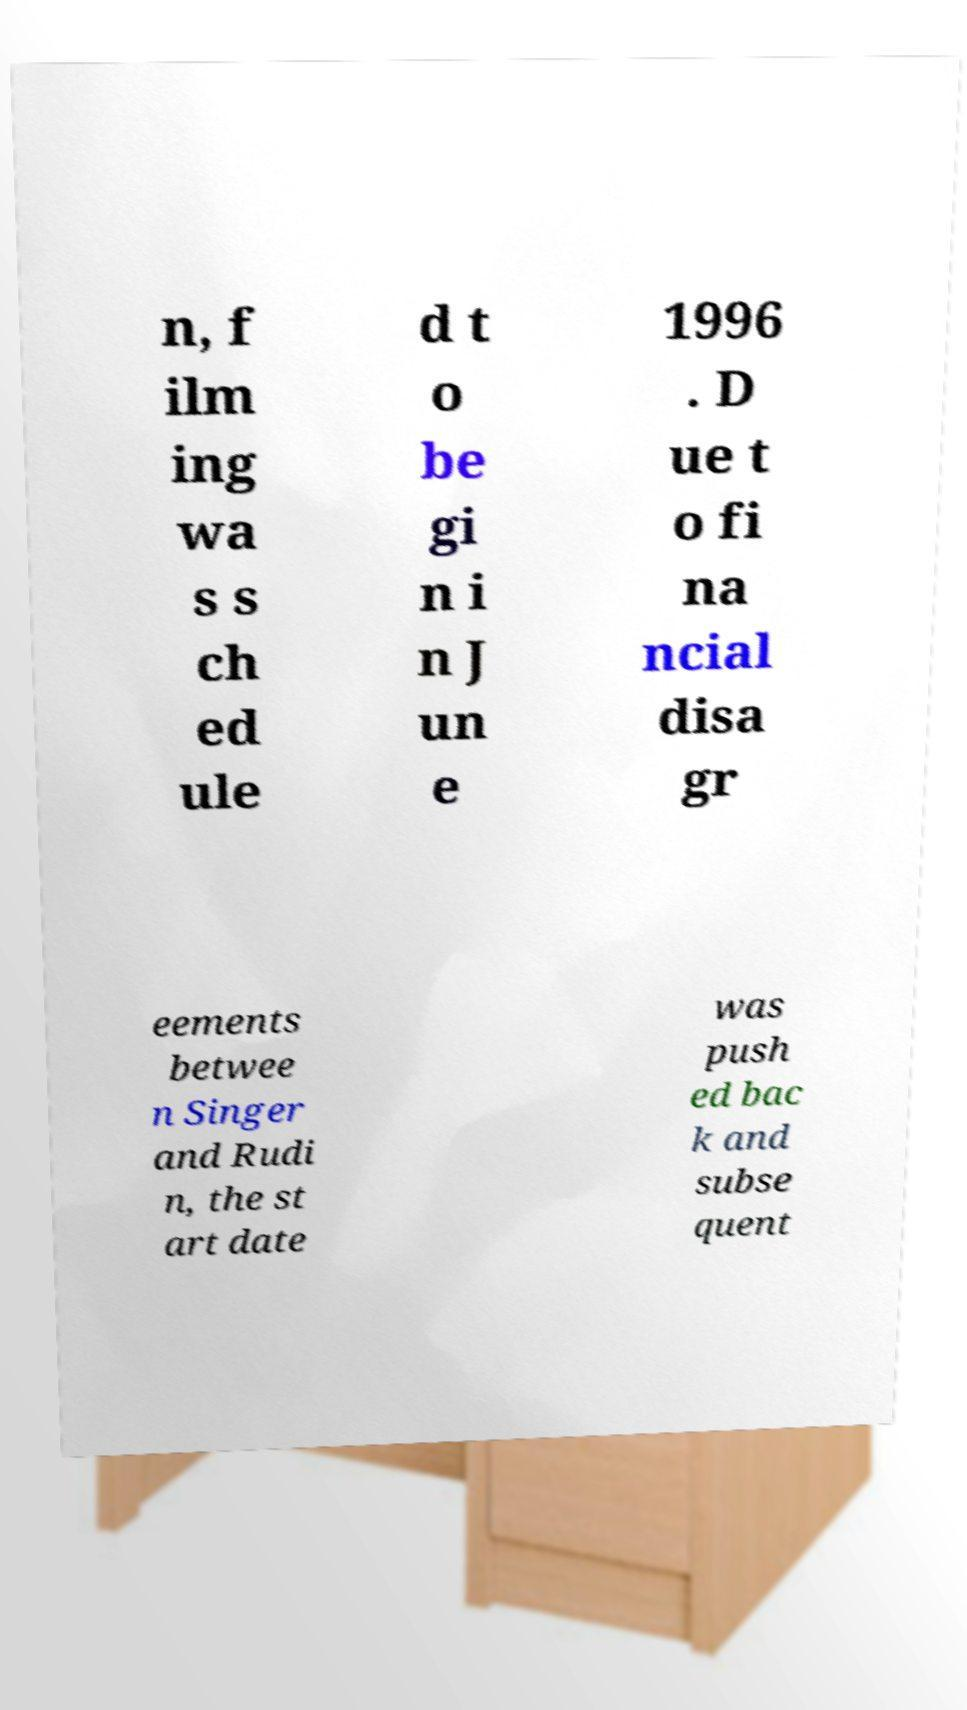Could you extract and type out the text from this image? n, f ilm ing wa s s ch ed ule d t o be gi n i n J un e 1996 . D ue t o fi na ncial disa gr eements betwee n Singer and Rudi n, the st art date was push ed bac k and subse quent 